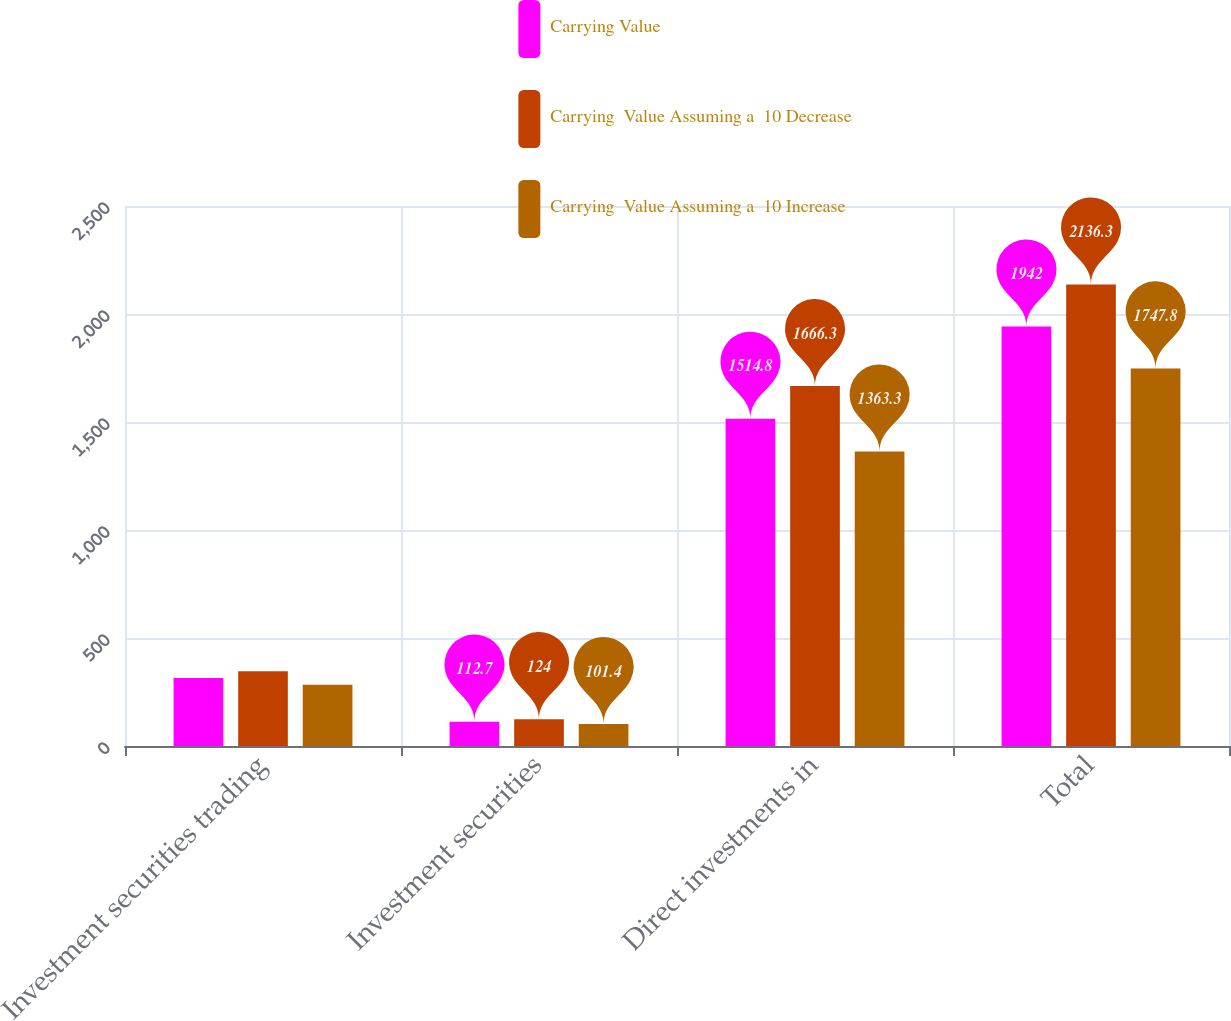<chart> <loc_0><loc_0><loc_500><loc_500><stacked_bar_chart><ecel><fcel>Investment securities trading<fcel>Investment securities<fcel>Direct investments in<fcel>Total<nl><fcel>Carrying Value<fcel>314.5<fcel>112.7<fcel>1514.8<fcel>1942<nl><fcel>Carrying  Value Assuming a  10 Decrease<fcel>346<fcel>124<fcel>1666.3<fcel>2136.3<nl><fcel>Carrying  Value Assuming a  10 Increase<fcel>283.1<fcel>101.4<fcel>1363.3<fcel>1747.8<nl></chart> 